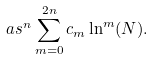Convert formula to latex. <formula><loc_0><loc_0><loc_500><loc_500>\ a s ^ { n } \sum _ { m = 0 } ^ { 2 n } c _ { m } \ln ^ { m } ( N ) .</formula> 